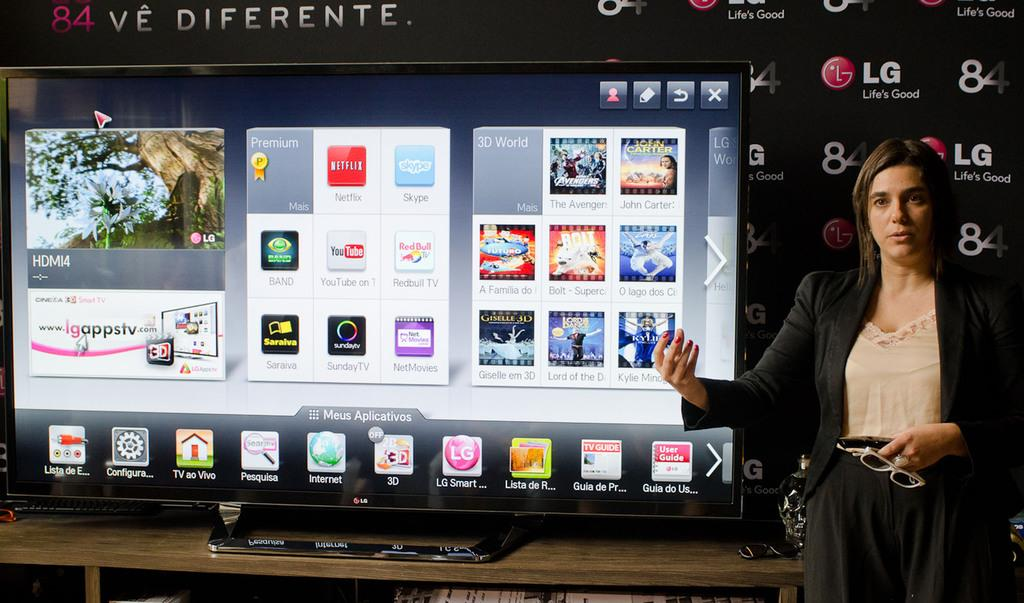Provide a one-sentence caption for the provided image. A woman stands by a display sponsored by LG. 